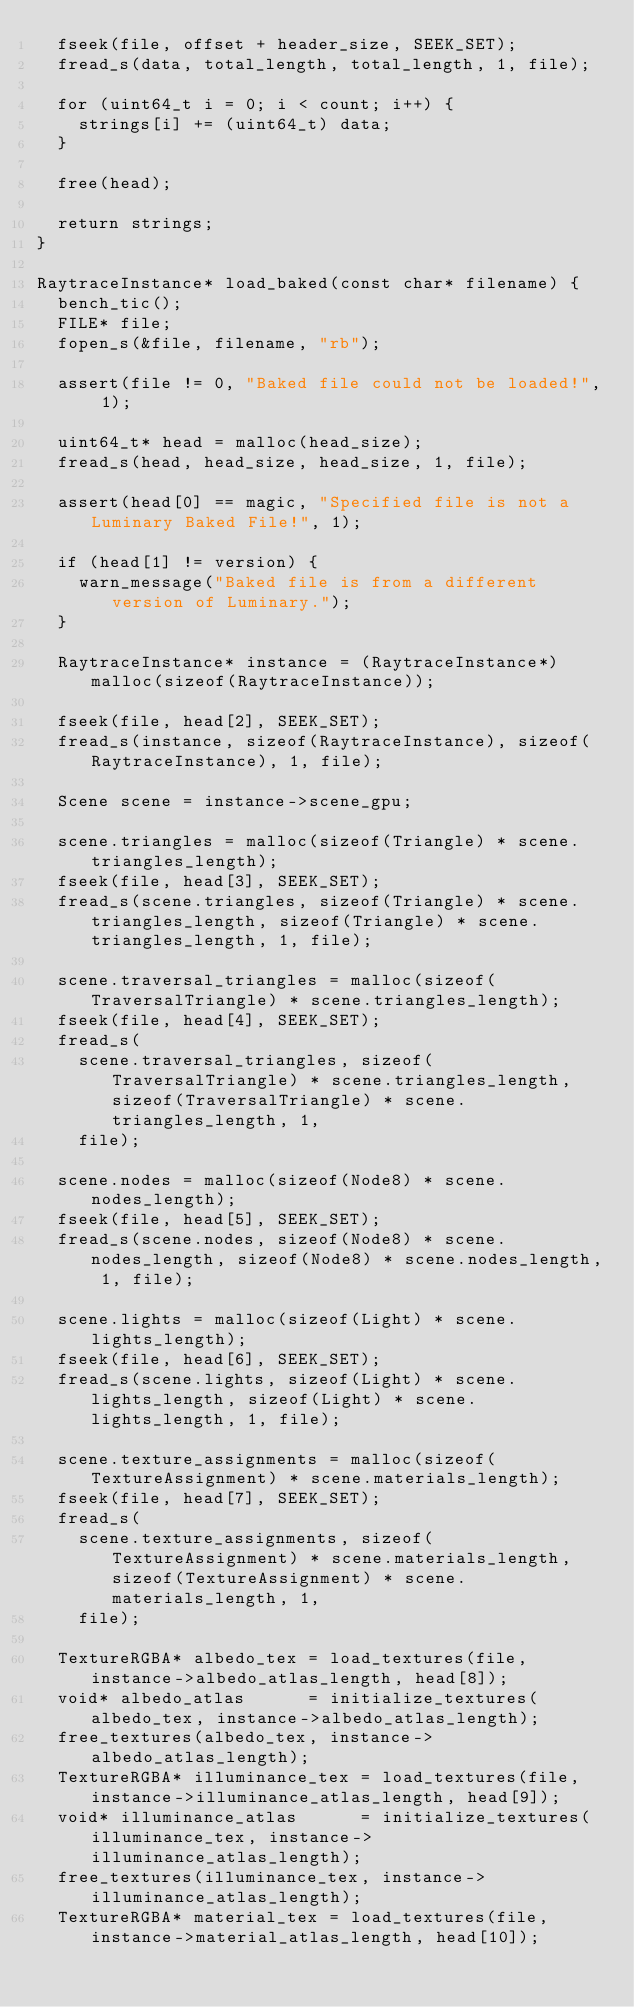<code> <loc_0><loc_0><loc_500><loc_500><_C_>  fseek(file, offset + header_size, SEEK_SET);
  fread_s(data, total_length, total_length, 1, file);

  for (uint64_t i = 0; i < count; i++) {
    strings[i] += (uint64_t) data;
  }

  free(head);

  return strings;
}

RaytraceInstance* load_baked(const char* filename) {
  bench_tic();
  FILE* file;
  fopen_s(&file, filename, "rb");

  assert(file != 0, "Baked file could not be loaded!", 1);

  uint64_t* head = malloc(head_size);
  fread_s(head, head_size, head_size, 1, file);

  assert(head[0] == magic, "Specified file is not a Luminary Baked File!", 1);

  if (head[1] != version) {
    warn_message("Baked file is from a different version of Luminary.");
  }

  RaytraceInstance* instance = (RaytraceInstance*) malloc(sizeof(RaytraceInstance));

  fseek(file, head[2], SEEK_SET);
  fread_s(instance, sizeof(RaytraceInstance), sizeof(RaytraceInstance), 1, file);

  Scene scene = instance->scene_gpu;

  scene.triangles = malloc(sizeof(Triangle) * scene.triangles_length);
  fseek(file, head[3], SEEK_SET);
  fread_s(scene.triangles, sizeof(Triangle) * scene.triangles_length, sizeof(Triangle) * scene.triangles_length, 1, file);

  scene.traversal_triangles = malloc(sizeof(TraversalTriangle) * scene.triangles_length);
  fseek(file, head[4], SEEK_SET);
  fread_s(
    scene.traversal_triangles, sizeof(TraversalTriangle) * scene.triangles_length, sizeof(TraversalTriangle) * scene.triangles_length, 1,
    file);

  scene.nodes = malloc(sizeof(Node8) * scene.nodes_length);
  fseek(file, head[5], SEEK_SET);
  fread_s(scene.nodes, sizeof(Node8) * scene.nodes_length, sizeof(Node8) * scene.nodes_length, 1, file);

  scene.lights = malloc(sizeof(Light) * scene.lights_length);
  fseek(file, head[6], SEEK_SET);
  fread_s(scene.lights, sizeof(Light) * scene.lights_length, sizeof(Light) * scene.lights_length, 1, file);

  scene.texture_assignments = malloc(sizeof(TextureAssignment) * scene.materials_length);
  fseek(file, head[7], SEEK_SET);
  fread_s(
    scene.texture_assignments, sizeof(TextureAssignment) * scene.materials_length, sizeof(TextureAssignment) * scene.materials_length, 1,
    file);

  TextureRGBA* albedo_tex = load_textures(file, instance->albedo_atlas_length, head[8]);
  void* albedo_atlas      = initialize_textures(albedo_tex, instance->albedo_atlas_length);
  free_textures(albedo_tex, instance->albedo_atlas_length);
  TextureRGBA* illuminance_tex = load_textures(file, instance->illuminance_atlas_length, head[9]);
  void* illuminance_atlas      = initialize_textures(illuminance_tex, instance->illuminance_atlas_length);
  free_textures(illuminance_tex, instance->illuminance_atlas_length);
  TextureRGBA* material_tex = load_textures(file, instance->material_atlas_length, head[10]);</code> 